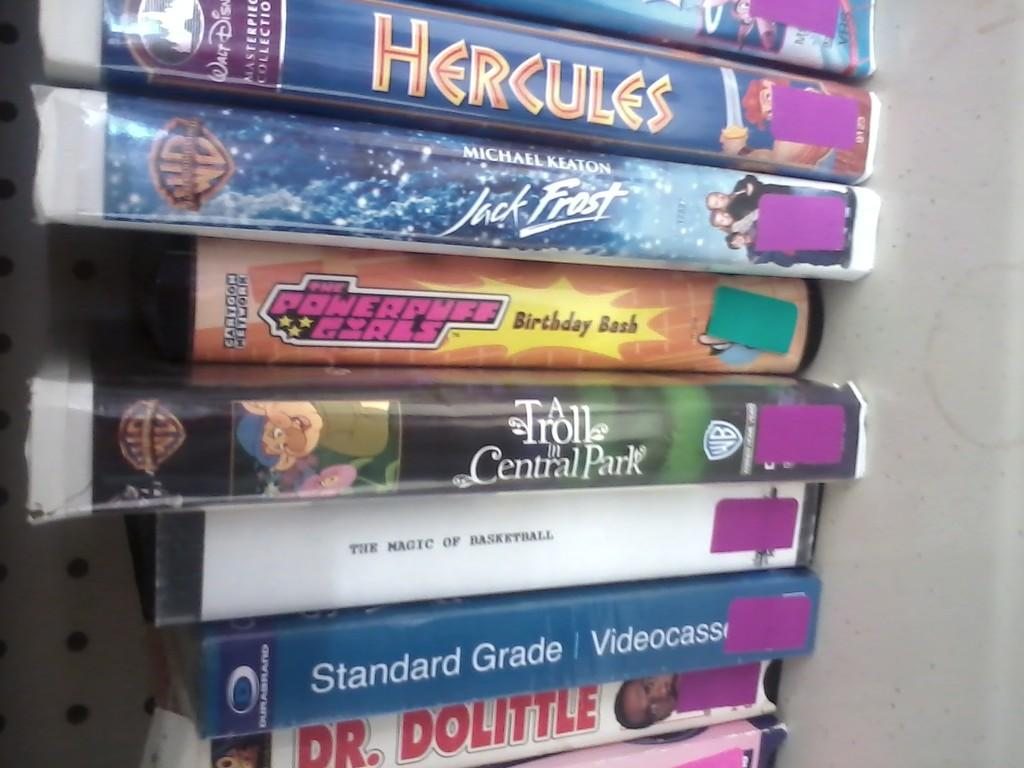Provide a one-sentence caption for the provided image. A stack of DVDs that are mostly cartoon such as Hercules and The Powerpuff Girls. 